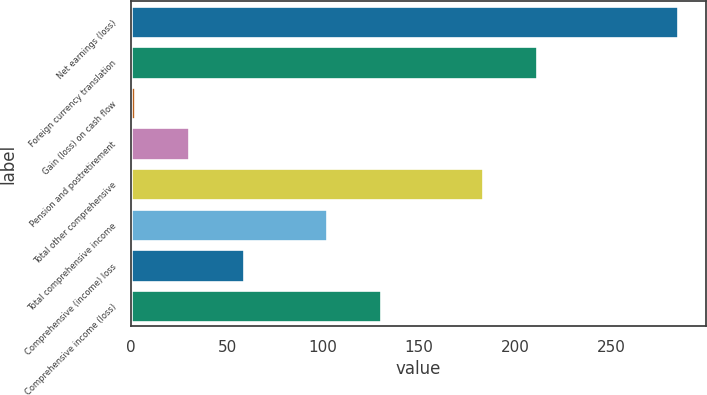<chart> <loc_0><loc_0><loc_500><loc_500><bar_chart><fcel>Net earnings (loss)<fcel>Foreign currency translation<fcel>Gain (loss) on cash flow<fcel>Pension and postretirement<fcel>Total other comprehensive<fcel>Total comprehensive income<fcel>Comprehensive (income) loss<fcel>Comprehensive income (loss)<nl><fcel>285<fcel>211.3<fcel>2<fcel>30.3<fcel>183<fcel>102<fcel>58.6<fcel>130.3<nl></chart> 